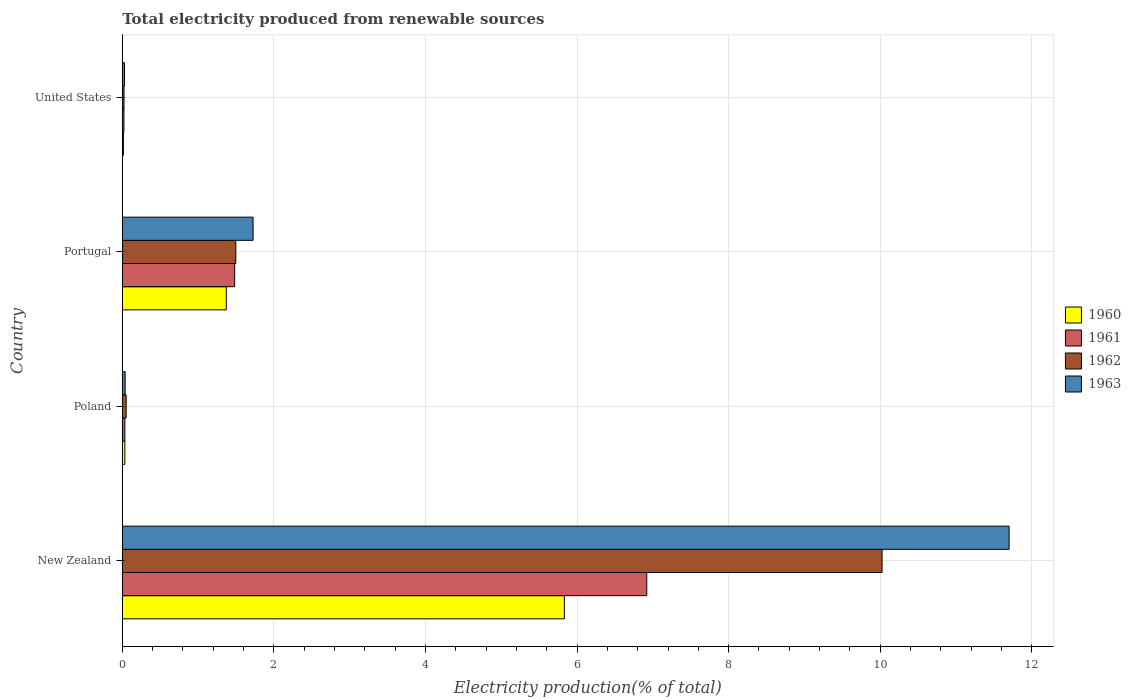Are the number of bars on each tick of the Y-axis equal?
Ensure brevity in your answer.  Yes. In how many cases, is the number of bars for a given country not equal to the number of legend labels?
Your answer should be very brief. 0. What is the total electricity produced in 1963 in Poland?
Give a very brief answer. 0.04. Across all countries, what is the maximum total electricity produced in 1963?
Give a very brief answer. 11.7. Across all countries, what is the minimum total electricity produced in 1962?
Your answer should be very brief. 0.02. In which country was the total electricity produced in 1961 maximum?
Provide a short and direct response. New Zealand. In which country was the total electricity produced in 1962 minimum?
Give a very brief answer. United States. What is the total total electricity produced in 1960 in the graph?
Give a very brief answer. 7.25. What is the difference between the total electricity produced in 1963 in New Zealand and that in United States?
Offer a very short reply. 11.67. What is the difference between the total electricity produced in 1960 in Poland and the total electricity produced in 1962 in Portugal?
Make the answer very short. -1.46. What is the average total electricity produced in 1961 per country?
Keep it short and to the point. 2.11. What is the difference between the total electricity produced in 1963 and total electricity produced in 1962 in Poland?
Offer a terse response. -0.01. In how many countries, is the total electricity produced in 1961 greater than 2.4 %?
Make the answer very short. 1. What is the ratio of the total electricity produced in 1960 in New Zealand to that in Portugal?
Your answer should be compact. 4.25. Is the total electricity produced in 1963 in New Zealand less than that in United States?
Your response must be concise. No. What is the difference between the highest and the second highest total electricity produced in 1961?
Make the answer very short. 5.44. What is the difference between the highest and the lowest total electricity produced in 1963?
Offer a terse response. 11.67. Is it the case that in every country, the sum of the total electricity produced in 1960 and total electricity produced in 1962 is greater than the total electricity produced in 1963?
Provide a succinct answer. Yes. How many countries are there in the graph?
Make the answer very short. 4. What is the difference between two consecutive major ticks on the X-axis?
Your response must be concise. 2. Are the values on the major ticks of X-axis written in scientific E-notation?
Make the answer very short. No. Does the graph contain grids?
Ensure brevity in your answer.  Yes. Where does the legend appear in the graph?
Ensure brevity in your answer.  Center right. How are the legend labels stacked?
Provide a short and direct response. Vertical. What is the title of the graph?
Your response must be concise. Total electricity produced from renewable sources. What is the label or title of the Y-axis?
Your answer should be very brief. Country. What is the Electricity production(% of total) in 1960 in New Zealand?
Offer a very short reply. 5.83. What is the Electricity production(% of total) in 1961 in New Zealand?
Ensure brevity in your answer.  6.92. What is the Electricity production(% of total) of 1962 in New Zealand?
Provide a short and direct response. 10.02. What is the Electricity production(% of total) of 1963 in New Zealand?
Your response must be concise. 11.7. What is the Electricity production(% of total) in 1960 in Poland?
Make the answer very short. 0.03. What is the Electricity production(% of total) in 1961 in Poland?
Offer a very short reply. 0.03. What is the Electricity production(% of total) in 1962 in Poland?
Provide a short and direct response. 0.05. What is the Electricity production(% of total) in 1963 in Poland?
Your response must be concise. 0.04. What is the Electricity production(% of total) of 1960 in Portugal?
Your answer should be very brief. 1.37. What is the Electricity production(% of total) in 1961 in Portugal?
Ensure brevity in your answer.  1.48. What is the Electricity production(% of total) in 1962 in Portugal?
Ensure brevity in your answer.  1.5. What is the Electricity production(% of total) of 1963 in Portugal?
Provide a succinct answer. 1.73. What is the Electricity production(% of total) of 1960 in United States?
Give a very brief answer. 0.02. What is the Electricity production(% of total) in 1961 in United States?
Your answer should be compact. 0.02. What is the Electricity production(% of total) of 1962 in United States?
Provide a succinct answer. 0.02. What is the Electricity production(% of total) of 1963 in United States?
Your answer should be compact. 0.03. Across all countries, what is the maximum Electricity production(% of total) in 1960?
Provide a succinct answer. 5.83. Across all countries, what is the maximum Electricity production(% of total) in 1961?
Give a very brief answer. 6.92. Across all countries, what is the maximum Electricity production(% of total) of 1962?
Your answer should be compact. 10.02. Across all countries, what is the maximum Electricity production(% of total) in 1963?
Keep it short and to the point. 11.7. Across all countries, what is the minimum Electricity production(% of total) of 1960?
Offer a terse response. 0.02. Across all countries, what is the minimum Electricity production(% of total) of 1961?
Make the answer very short. 0.02. Across all countries, what is the minimum Electricity production(% of total) in 1962?
Provide a short and direct response. 0.02. Across all countries, what is the minimum Electricity production(% of total) in 1963?
Your response must be concise. 0.03. What is the total Electricity production(% of total) in 1960 in the graph?
Keep it short and to the point. 7.25. What is the total Electricity production(% of total) in 1961 in the graph?
Provide a short and direct response. 8.46. What is the total Electricity production(% of total) in 1962 in the graph?
Provide a succinct answer. 11.6. What is the total Electricity production(% of total) of 1963 in the graph?
Keep it short and to the point. 13.49. What is the difference between the Electricity production(% of total) in 1960 in New Zealand and that in Poland?
Keep it short and to the point. 5.8. What is the difference between the Electricity production(% of total) in 1961 in New Zealand and that in Poland?
Offer a very short reply. 6.89. What is the difference between the Electricity production(% of total) in 1962 in New Zealand and that in Poland?
Provide a succinct answer. 9.97. What is the difference between the Electricity production(% of total) of 1963 in New Zealand and that in Poland?
Provide a short and direct response. 11.66. What is the difference between the Electricity production(% of total) of 1960 in New Zealand and that in Portugal?
Offer a very short reply. 4.46. What is the difference between the Electricity production(% of total) in 1961 in New Zealand and that in Portugal?
Provide a short and direct response. 5.44. What is the difference between the Electricity production(% of total) in 1962 in New Zealand and that in Portugal?
Offer a very short reply. 8.53. What is the difference between the Electricity production(% of total) in 1963 in New Zealand and that in Portugal?
Provide a short and direct response. 9.97. What is the difference between the Electricity production(% of total) in 1960 in New Zealand and that in United States?
Keep it short and to the point. 5.82. What is the difference between the Electricity production(% of total) of 1961 in New Zealand and that in United States?
Your response must be concise. 6.9. What is the difference between the Electricity production(% of total) in 1962 in New Zealand and that in United States?
Ensure brevity in your answer.  10. What is the difference between the Electricity production(% of total) in 1963 in New Zealand and that in United States?
Ensure brevity in your answer.  11.67. What is the difference between the Electricity production(% of total) of 1960 in Poland and that in Portugal?
Ensure brevity in your answer.  -1.34. What is the difference between the Electricity production(% of total) in 1961 in Poland and that in Portugal?
Make the answer very short. -1.45. What is the difference between the Electricity production(% of total) of 1962 in Poland and that in Portugal?
Keep it short and to the point. -1.45. What is the difference between the Electricity production(% of total) of 1963 in Poland and that in Portugal?
Provide a succinct answer. -1.69. What is the difference between the Electricity production(% of total) of 1960 in Poland and that in United States?
Your response must be concise. 0.02. What is the difference between the Electricity production(% of total) in 1961 in Poland and that in United States?
Make the answer very short. 0.01. What is the difference between the Electricity production(% of total) in 1962 in Poland and that in United States?
Your answer should be compact. 0.03. What is the difference between the Electricity production(% of total) of 1963 in Poland and that in United States?
Your answer should be very brief. 0.01. What is the difference between the Electricity production(% of total) in 1960 in Portugal and that in United States?
Your answer should be compact. 1.36. What is the difference between the Electricity production(% of total) in 1961 in Portugal and that in United States?
Provide a short and direct response. 1.46. What is the difference between the Electricity production(% of total) of 1962 in Portugal and that in United States?
Your response must be concise. 1.48. What is the difference between the Electricity production(% of total) of 1963 in Portugal and that in United States?
Provide a succinct answer. 1.7. What is the difference between the Electricity production(% of total) in 1960 in New Zealand and the Electricity production(% of total) in 1961 in Poland?
Offer a very short reply. 5.8. What is the difference between the Electricity production(% of total) in 1960 in New Zealand and the Electricity production(% of total) in 1962 in Poland?
Offer a terse response. 5.78. What is the difference between the Electricity production(% of total) of 1960 in New Zealand and the Electricity production(% of total) of 1963 in Poland?
Make the answer very short. 5.79. What is the difference between the Electricity production(% of total) of 1961 in New Zealand and the Electricity production(% of total) of 1962 in Poland?
Make the answer very short. 6.87. What is the difference between the Electricity production(% of total) of 1961 in New Zealand and the Electricity production(% of total) of 1963 in Poland?
Offer a very short reply. 6.88. What is the difference between the Electricity production(% of total) of 1962 in New Zealand and the Electricity production(% of total) of 1963 in Poland?
Your response must be concise. 9.99. What is the difference between the Electricity production(% of total) in 1960 in New Zealand and the Electricity production(% of total) in 1961 in Portugal?
Provide a succinct answer. 4.35. What is the difference between the Electricity production(% of total) in 1960 in New Zealand and the Electricity production(% of total) in 1962 in Portugal?
Provide a short and direct response. 4.33. What is the difference between the Electricity production(% of total) of 1960 in New Zealand and the Electricity production(% of total) of 1963 in Portugal?
Provide a short and direct response. 4.11. What is the difference between the Electricity production(% of total) in 1961 in New Zealand and the Electricity production(% of total) in 1962 in Portugal?
Make the answer very short. 5.42. What is the difference between the Electricity production(% of total) in 1961 in New Zealand and the Electricity production(% of total) in 1963 in Portugal?
Offer a very short reply. 5.19. What is the difference between the Electricity production(% of total) in 1962 in New Zealand and the Electricity production(% of total) in 1963 in Portugal?
Your answer should be very brief. 8.3. What is the difference between the Electricity production(% of total) of 1960 in New Zealand and the Electricity production(% of total) of 1961 in United States?
Keep it short and to the point. 5.81. What is the difference between the Electricity production(% of total) of 1960 in New Zealand and the Electricity production(% of total) of 1962 in United States?
Your answer should be compact. 5.81. What is the difference between the Electricity production(% of total) in 1960 in New Zealand and the Electricity production(% of total) in 1963 in United States?
Make the answer very short. 5.8. What is the difference between the Electricity production(% of total) of 1961 in New Zealand and the Electricity production(% of total) of 1962 in United States?
Keep it short and to the point. 6.9. What is the difference between the Electricity production(% of total) in 1961 in New Zealand and the Electricity production(% of total) in 1963 in United States?
Offer a terse response. 6.89. What is the difference between the Electricity production(% of total) of 1962 in New Zealand and the Electricity production(% of total) of 1963 in United States?
Provide a succinct answer. 10. What is the difference between the Electricity production(% of total) of 1960 in Poland and the Electricity production(% of total) of 1961 in Portugal?
Make the answer very short. -1.45. What is the difference between the Electricity production(% of total) of 1960 in Poland and the Electricity production(% of total) of 1962 in Portugal?
Your answer should be compact. -1.46. What is the difference between the Electricity production(% of total) in 1960 in Poland and the Electricity production(% of total) in 1963 in Portugal?
Your answer should be very brief. -1.69. What is the difference between the Electricity production(% of total) in 1961 in Poland and the Electricity production(% of total) in 1962 in Portugal?
Your answer should be compact. -1.46. What is the difference between the Electricity production(% of total) of 1961 in Poland and the Electricity production(% of total) of 1963 in Portugal?
Offer a very short reply. -1.69. What is the difference between the Electricity production(% of total) of 1962 in Poland and the Electricity production(% of total) of 1963 in Portugal?
Your answer should be compact. -1.67. What is the difference between the Electricity production(% of total) in 1960 in Poland and the Electricity production(% of total) in 1961 in United States?
Keep it short and to the point. 0.01. What is the difference between the Electricity production(% of total) in 1960 in Poland and the Electricity production(% of total) in 1962 in United States?
Your answer should be very brief. 0.01. What is the difference between the Electricity production(% of total) in 1960 in Poland and the Electricity production(% of total) in 1963 in United States?
Ensure brevity in your answer.  0. What is the difference between the Electricity production(% of total) of 1961 in Poland and the Electricity production(% of total) of 1962 in United States?
Offer a very short reply. 0.01. What is the difference between the Electricity production(% of total) in 1961 in Poland and the Electricity production(% of total) in 1963 in United States?
Provide a succinct answer. 0. What is the difference between the Electricity production(% of total) in 1962 in Poland and the Electricity production(% of total) in 1963 in United States?
Keep it short and to the point. 0.02. What is the difference between the Electricity production(% of total) in 1960 in Portugal and the Electricity production(% of total) in 1961 in United States?
Your answer should be compact. 1.35. What is the difference between the Electricity production(% of total) of 1960 in Portugal and the Electricity production(% of total) of 1962 in United States?
Make the answer very short. 1.35. What is the difference between the Electricity production(% of total) of 1960 in Portugal and the Electricity production(% of total) of 1963 in United States?
Provide a succinct answer. 1.34. What is the difference between the Electricity production(% of total) of 1961 in Portugal and the Electricity production(% of total) of 1962 in United States?
Offer a terse response. 1.46. What is the difference between the Electricity production(% of total) of 1961 in Portugal and the Electricity production(% of total) of 1963 in United States?
Your answer should be very brief. 1.45. What is the difference between the Electricity production(% of total) in 1962 in Portugal and the Electricity production(% of total) in 1963 in United States?
Ensure brevity in your answer.  1.47. What is the average Electricity production(% of total) of 1960 per country?
Your answer should be compact. 1.81. What is the average Electricity production(% of total) of 1961 per country?
Provide a succinct answer. 2.11. What is the average Electricity production(% of total) of 1962 per country?
Your response must be concise. 2.9. What is the average Electricity production(% of total) in 1963 per country?
Offer a very short reply. 3.37. What is the difference between the Electricity production(% of total) in 1960 and Electricity production(% of total) in 1961 in New Zealand?
Your answer should be compact. -1.09. What is the difference between the Electricity production(% of total) of 1960 and Electricity production(% of total) of 1962 in New Zealand?
Offer a terse response. -4.19. What is the difference between the Electricity production(% of total) in 1960 and Electricity production(% of total) in 1963 in New Zealand?
Make the answer very short. -5.87. What is the difference between the Electricity production(% of total) in 1961 and Electricity production(% of total) in 1962 in New Zealand?
Offer a terse response. -3.1. What is the difference between the Electricity production(% of total) in 1961 and Electricity production(% of total) in 1963 in New Zealand?
Your response must be concise. -4.78. What is the difference between the Electricity production(% of total) in 1962 and Electricity production(% of total) in 1963 in New Zealand?
Keep it short and to the point. -1.68. What is the difference between the Electricity production(% of total) of 1960 and Electricity production(% of total) of 1961 in Poland?
Provide a short and direct response. 0. What is the difference between the Electricity production(% of total) in 1960 and Electricity production(% of total) in 1962 in Poland?
Make the answer very short. -0.02. What is the difference between the Electricity production(% of total) of 1960 and Electricity production(% of total) of 1963 in Poland?
Give a very brief answer. -0. What is the difference between the Electricity production(% of total) of 1961 and Electricity production(% of total) of 1962 in Poland?
Ensure brevity in your answer.  -0.02. What is the difference between the Electricity production(% of total) in 1961 and Electricity production(% of total) in 1963 in Poland?
Offer a very short reply. -0. What is the difference between the Electricity production(% of total) of 1962 and Electricity production(% of total) of 1963 in Poland?
Give a very brief answer. 0.01. What is the difference between the Electricity production(% of total) of 1960 and Electricity production(% of total) of 1961 in Portugal?
Your answer should be compact. -0.11. What is the difference between the Electricity production(% of total) in 1960 and Electricity production(% of total) in 1962 in Portugal?
Provide a succinct answer. -0.13. What is the difference between the Electricity production(% of total) in 1960 and Electricity production(% of total) in 1963 in Portugal?
Keep it short and to the point. -0.35. What is the difference between the Electricity production(% of total) in 1961 and Electricity production(% of total) in 1962 in Portugal?
Offer a terse response. -0.02. What is the difference between the Electricity production(% of total) of 1961 and Electricity production(% of total) of 1963 in Portugal?
Keep it short and to the point. -0.24. What is the difference between the Electricity production(% of total) in 1962 and Electricity production(% of total) in 1963 in Portugal?
Your response must be concise. -0.23. What is the difference between the Electricity production(% of total) in 1960 and Electricity production(% of total) in 1961 in United States?
Make the answer very short. -0.01. What is the difference between the Electricity production(% of total) in 1960 and Electricity production(% of total) in 1962 in United States?
Offer a terse response. -0.01. What is the difference between the Electricity production(% of total) of 1960 and Electricity production(% of total) of 1963 in United States?
Your answer should be very brief. -0.01. What is the difference between the Electricity production(% of total) of 1961 and Electricity production(% of total) of 1962 in United States?
Provide a succinct answer. -0. What is the difference between the Electricity production(% of total) in 1961 and Electricity production(% of total) in 1963 in United States?
Your answer should be compact. -0.01. What is the difference between the Electricity production(% of total) in 1962 and Electricity production(% of total) in 1963 in United States?
Your answer should be compact. -0.01. What is the ratio of the Electricity production(% of total) in 1960 in New Zealand to that in Poland?
Provide a succinct answer. 170.79. What is the ratio of the Electricity production(% of total) in 1961 in New Zealand to that in Poland?
Provide a short and direct response. 202.83. What is the ratio of the Electricity production(% of total) in 1962 in New Zealand to that in Poland?
Give a very brief answer. 196.95. What is the ratio of the Electricity production(% of total) of 1963 in New Zealand to that in Poland?
Give a very brief answer. 308.73. What is the ratio of the Electricity production(% of total) of 1960 in New Zealand to that in Portugal?
Ensure brevity in your answer.  4.25. What is the ratio of the Electricity production(% of total) in 1961 in New Zealand to that in Portugal?
Your answer should be compact. 4.67. What is the ratio of the Electricity production(% of total) of 1962 in New Zealand to that in Portugal?
Give a very brief answer. 6.69. What is the ratio of the Electricity production(% of total) in 1963 in New Zealand to that in Portugal?
Provide a succinct answer. 6.78. What is the ratio of the Electricity production(% of total) in 1960 in New Zealand to that in United States?
Ensure brevity in your answer.  382.31. What is the ratio of the Electricity production(% of total) of 1961 in New Zealand to that in United States?
Ensure brevity in your answer.  321.25. What is the ratio of the Electricity production(% of total) of 1962 in New Zealand to that in United States?
Provide a short and direct response. 439.93. What is the ratio of the Electricity production(% of total) of 1963 in New Zealand to that in United States?
Provide a short and direct response. 397.5. What is the ratio of the Electricity production(% of total) in 1960 in Poland to that in Portugal?
Your answer should be compact. 0.02. What is the ratio of the Electricity production(% of total) of 1961 in Poland to that in Portugal?
Keep it short and to the point. 0.02. What is the ratio of the Electricity production(% of total) of 1962 in Poland to that in Portugal?
Your answer should be compact. 0.03. What is the ratio of the Electricity production(% of total) in 1963 in Poland to that in Portugal?
Your response must be concise. 0.02. What is the ratio of the Electricity production(% of total) of 1960 in Poland to that in United States?
Offer a very short reply. 2.24. What is the ratio of the Electricity production(% of total) of 1961 in Poland to that in United States?
Give a very brief answer. 1.58. What is the ratio of the Electricity production(% of total) of 1962 in Poland to that in United States?
Offer a very short reply. 2.23. What is the ratio of the Electricity production(% of total) in 1963 in Poland to that in United States?
Keep it short and to the point. 1.29. What is the ratio of the Electricity production(% of total) of 1960 in Portugal to that in United States?
Your response must be concise. 89.96. What is the ratio of the Electricity production(% of total) in 1961 in Portugal to that in United States?
Your response must be concise. 68.83. What is the ratio of the Electricity production(% of total) in 1962 in Portugal to that in United States?
Offer a terse response. 65.74. What is the ratio of the Electricity production(% of total) of 1963 in Portugal to that in United States?
Give a very brief answer. 58.63. What is the difference between the highest and the second highest Electricity production(% of total) of 1960?
Your answer should be compact. 4.46. What is the difference between the highest and the second highest Electricity production(% of total) in 1961?
Your response must be concise. 5.44. What is the difference between the highest and the second highest Electricity production(% of total) in 1962?
Your answer should be very brief. 8.53. What is the difference between the highest and the second highest Electricity production(% of total) of 1963?
Make the answer very short. 9.97. What is the difference between the highest and the lowest Electricity production(% of total) in 1960?
Your answer should be very brief. 5.82. What is the difference between the highest and the lowest Electricity production(% of total) of 1961?
Offer a very short reply. 6.9. What is the difference between the highest and the lowest Electricity production(% of total) in 1962?
Your answer should be very brief. 10. What is the difference between the highest and the lowest Electricity production(% of total) in 1963?
Your response must be concise. 11.67. 